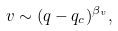Convert formula to latex. <formula><loc_0><loc_0><loc_500><loc_500>v \sim ( q - q _ { c } ) ^ { \beta _ { v } } ,</formula> 